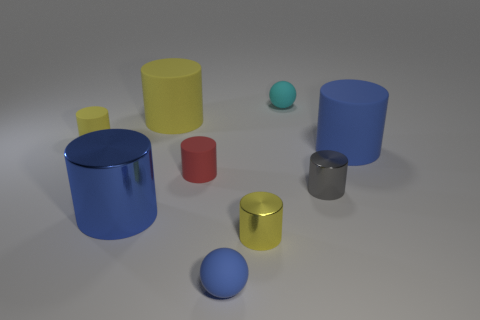Subtract all green balls. How many yellow cylinders are left? 3 Subtract 3 cylinders. How many cylinders are left? 4 Subtract all yellow cylinders. How many cylinders are left? 4 Subtract all gray cylinders. How many cylinders are left? 6 Subtract all purple cylinders. Subtract all green spheres. How many cylinders are left? 7 Add 1 large yellow matte cylinders. How many objects exist? 10 Subtract all cylinders. How many objects are left? 2 Subtract all brown spheres. Subtract all cyan spheres. How many objects are left? 8 Add 4 small metal cylinders. How many small metal cylinders are left? 6 Add 3 yellow matte things. How many yellow matte things exist? 5 